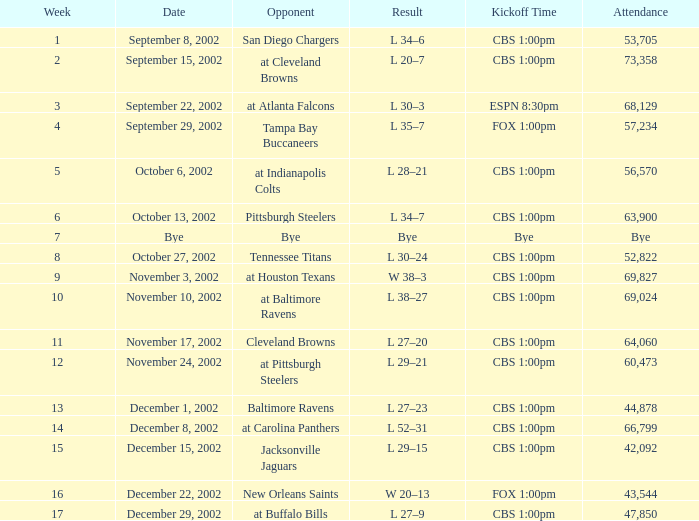How many people attended the game with a kickoff time of cbs 1:00pm, in a week earlier than 8, on September 15, 2002? 73358.0. 